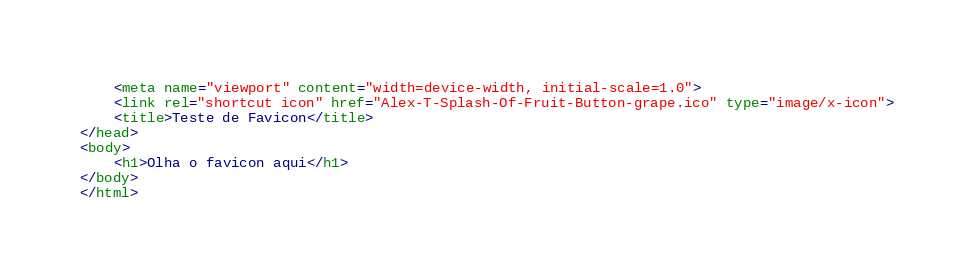<code> <loc_0><loc_0><loc_500><loc_500><_HTML_>    <meta name="viewport" content="width=device-width, initial-scale=1.0">
    <link rel="shortcut icon" href="Alex-T-Splash-Of-Fruit-Button-grape.ico" type="image/x-icon">
    <title>Teste de Favicon</title>
</head>
<body>
    <h1>Olha o favicon aqui</h1>    
</body>
</html></code> 